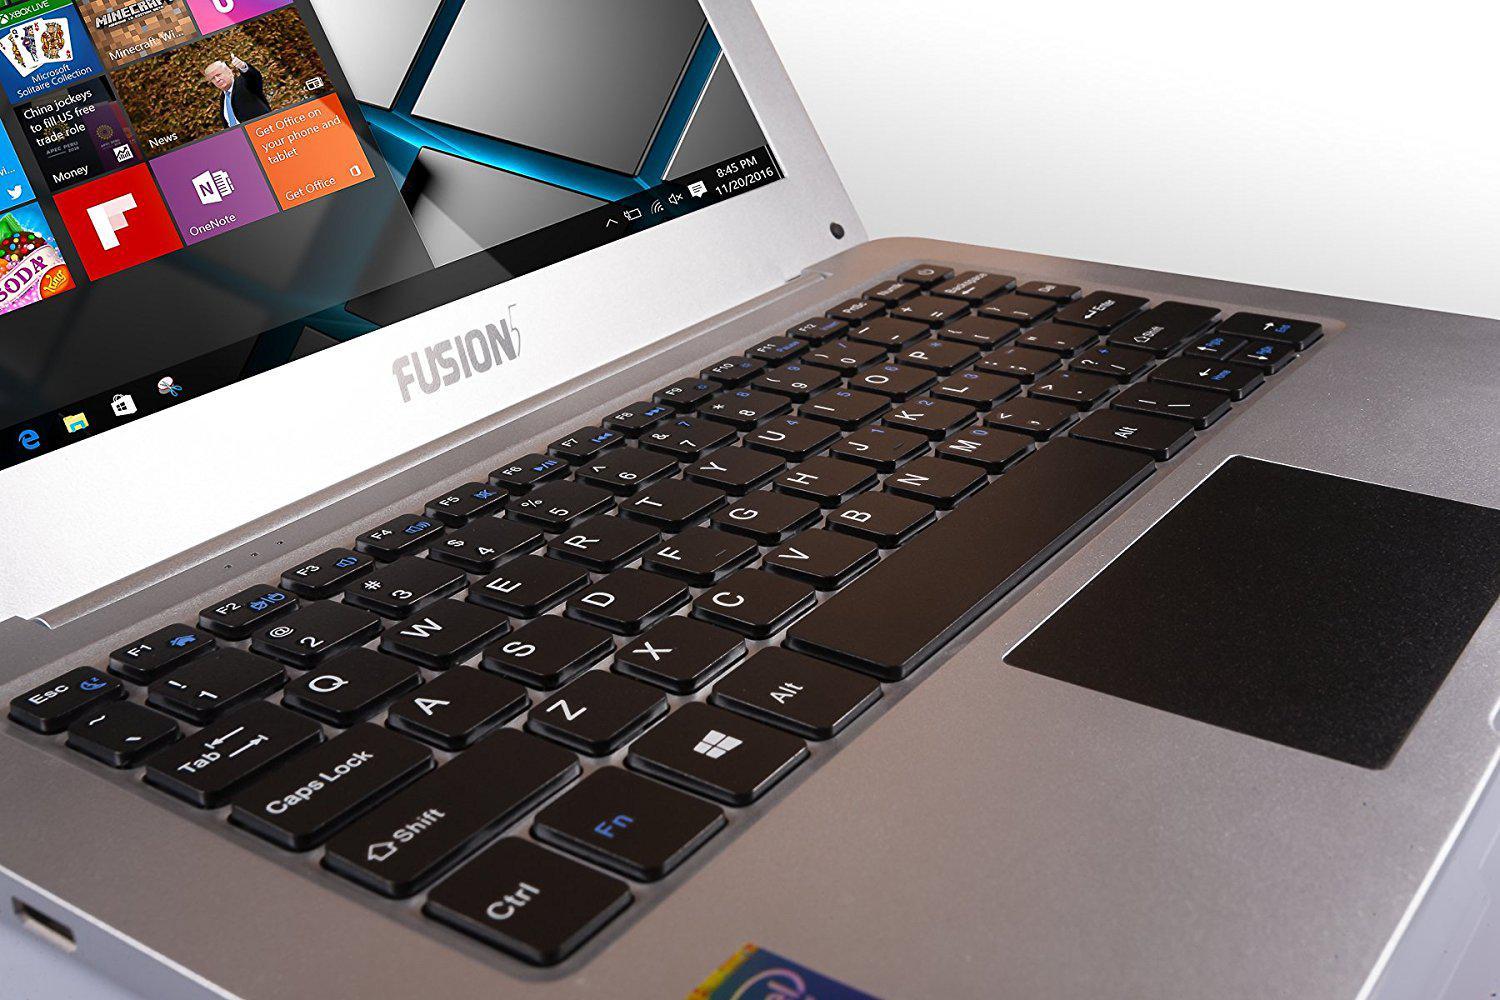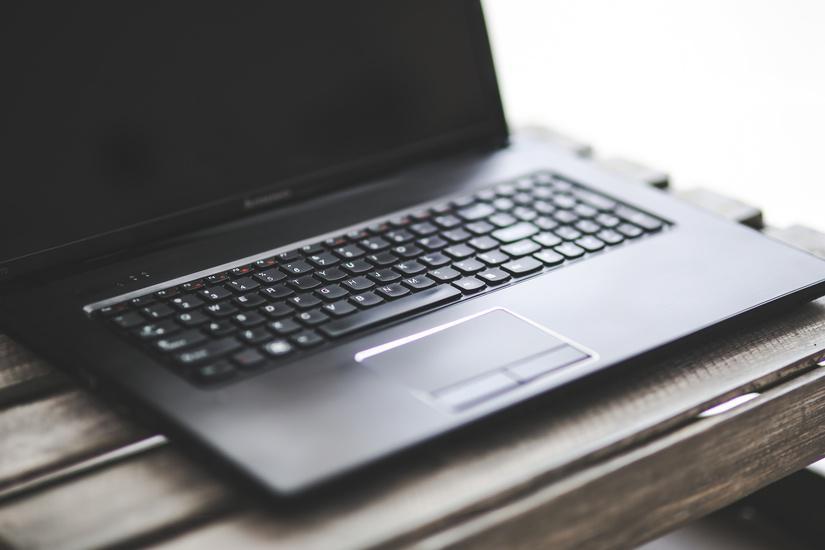The first image is the image on the left, the second image is the image on the right. For the images shown, is this caption "One image shows a hand reaching for something plugged into the side of an open laptop." true? Answer yes or no. No. The first image is the image on the left, the second image is the image on the right. Analyze the images presented: Is the assertion "In at least one image there is a black laptop that is open and turned right." valid? Answer yes or no. Yes. 